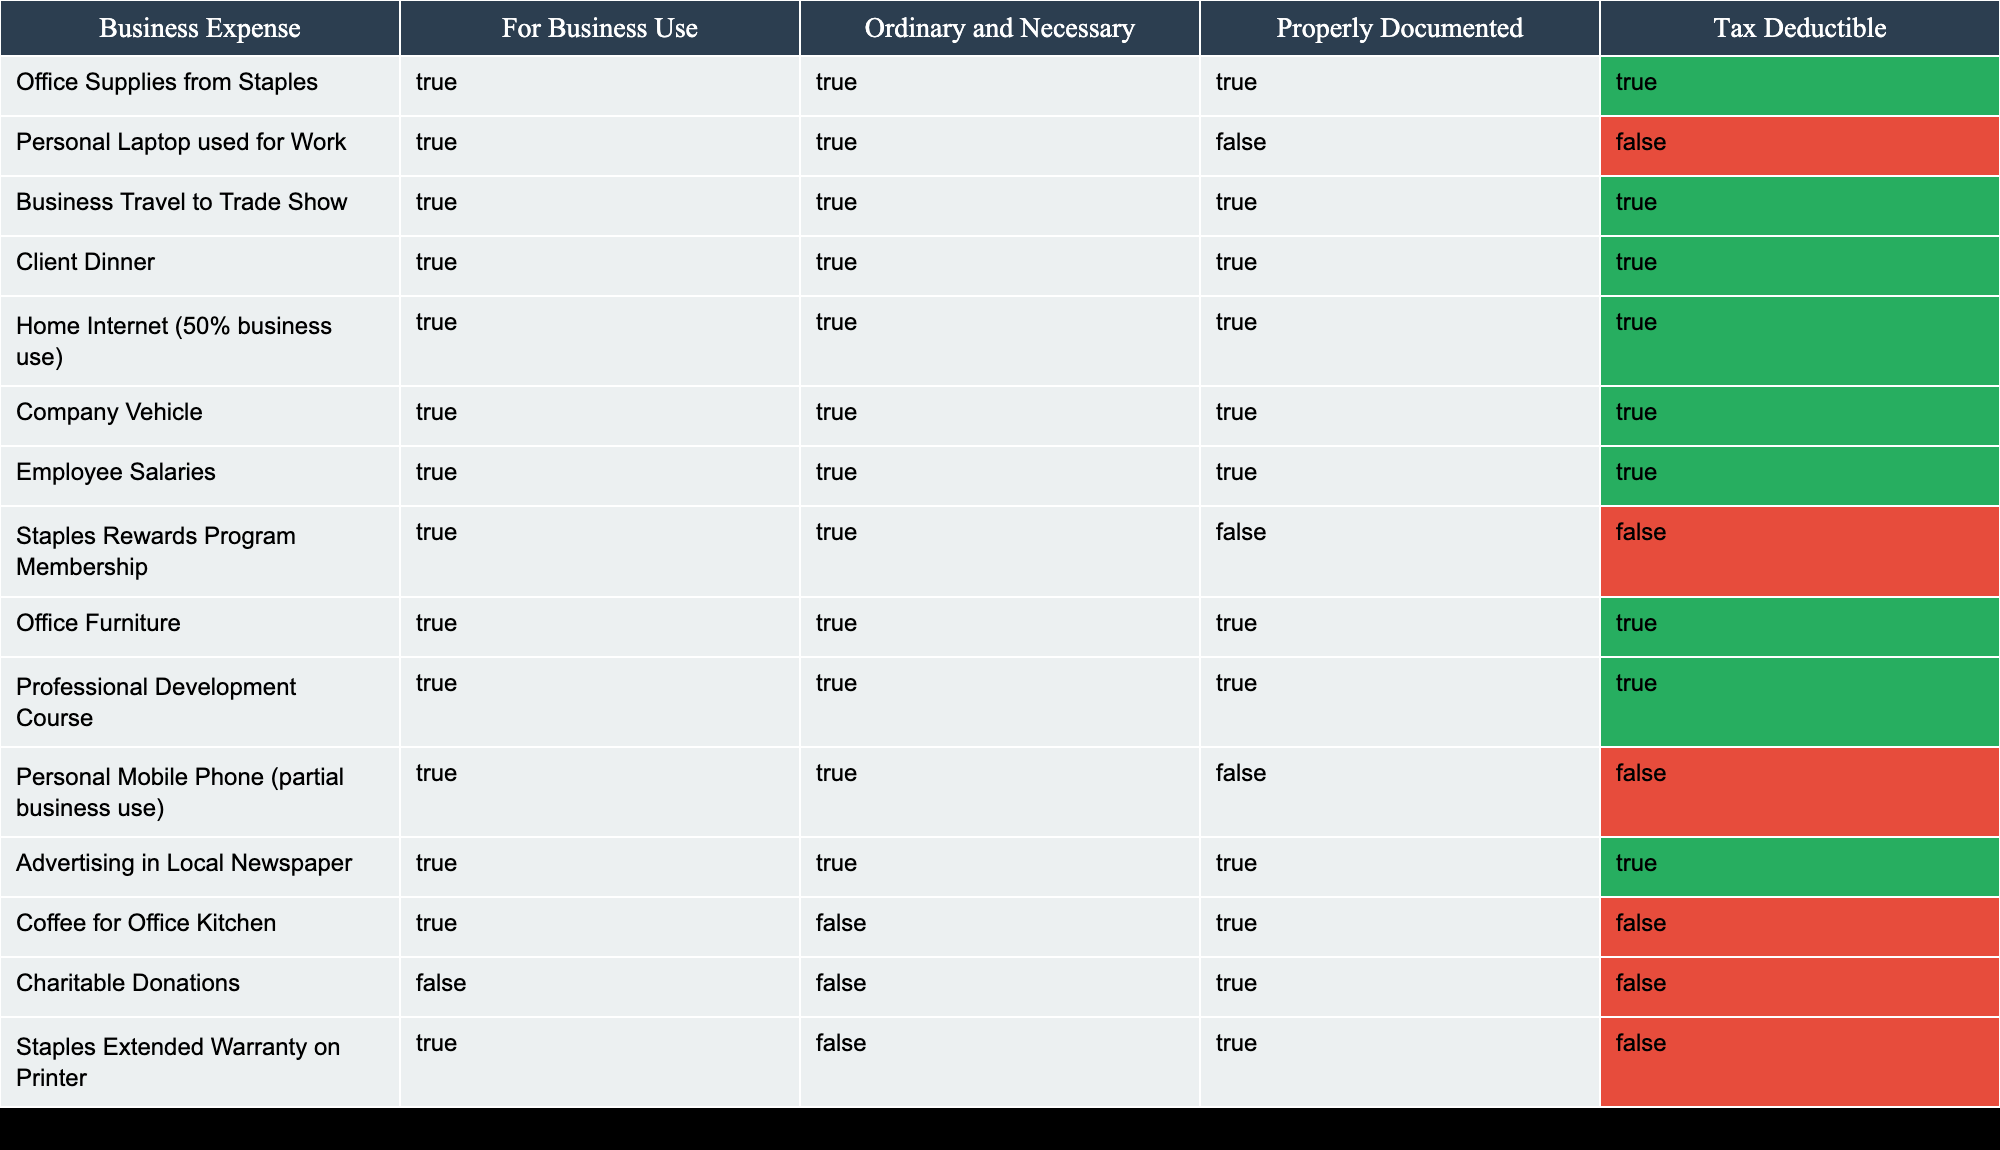What is the tax deduction eligibility of office supplies from Staples? According to the table, office supplies from Staples are classified as being for business use, ordinary and necessary, and properly documented. Therefore, they qualify as tax deductible.
Answer: True How many expenses have been classified as tax deductible? By counting the rows in the table, I find the following expenses are tax deductible: office supplies from Staples, business travel to trade show, client dinner, home internet, company vehicle, employee salaries, office furniture, professional development course, and advertising. This totals to 9 tax-deductible expenses.
Answer: 9 Is the personal laptop used for work considered a tax deductible expense? The table indicates that although the personal laptop is for business use and deemed ordinary and necessary, it is not properly documented, making it ineligible for tax deduction.
Answer: No What is the deduction eligibility status of the Staples Rewards Program membership? The table shows that the Staples Rewards Program membership is for business use and is ordinary and necessary, but it is not properly documented. This results in its classification as not tax deductible.
Answer: False How many total business expenses listed are not considered tax deductible? By reviewing the table, the non-tax deductible expenses are the personal laptop used for work, Staples Rewards Program membership, coffee for office kitchen, charitable donations, and Staples extended warranty on printer. That makes a total of 5 non-tax deductible expenses.
Answer: 5 Are all employee salaries fully tax deductible? The data shows that employee salaries are for business use, ordinary and necessary, and properly documented, confirming their eligibility for tax deduction.
Answer: Yes What is the total number of expenses that are both properly documented and tax deductible? By analyzing the table, the expenses that meet both criteria (properly documented and tax deductible) include: office supplies from Staples, business travel to trade show, client dinner, home internet, company vehicle, employee salaries, office furniture, professional development course, and advertising. There are 8 such expenses in total.
Answer: 8 Which expense has the highest number of criteria met for tax deductibility? The expenses with the highest number of criteria met (all three: for business use, ordinary and necessary, and properly documented) are office supplies from Staples, business travel to trade show, client dinner, home internet, company vehicle, employee salaries, office furniture, and professional development course. All of these meet all three criteria.
Answer: Multiple expenses Are advertising expenses considered as tax deductible according to the table? The table states that advertising in the local newspaper is for business use, ordinary and necessary, and properly documented, therefore it is classified as tax deductible.
Answer: Yes 